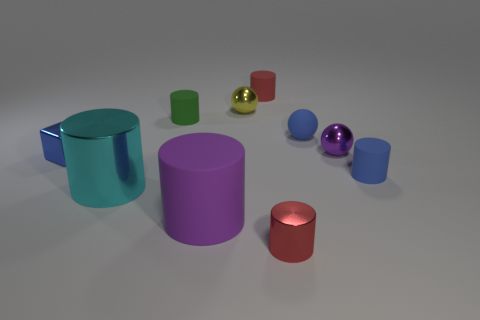How many spheres are the same color as the small metallic block?
Make the answer very short. 1. What number of large objects are either gray blocks or blocks?
Provide a short and direct response. 0. Do the purple thing that is right of the small red rubber cylinder and the big cyan object have the same material?
Make the answer very short. Yes. There is a small rubber cylinder that is on the right side of the purple metallic sphere; what is its color?
Your answer should be compact. Blue. Are there any purple rubber objects that have the same size as the blue matte sphere?
Your response must be concise. No. What is the material of the green cylinder that is the same size as the blue shiny cube?
Make the answer very short. Rubber. There is a matte ball; does it have the same size as the purple object that is behind the blue cube?
Provide a short and direct response. Yes. There is a tiny object that is in front of the cyan metallic cylinder; what is its material?
Offer a terse response. Metal. Is the number of purple shiny objects that are in front of the big matte thing the same as the number of cyan shiny spheres?
Your response must be concise. Yes. Is the matte ball the same size as the purple cylinder?
Your answer should be very brief. No. 